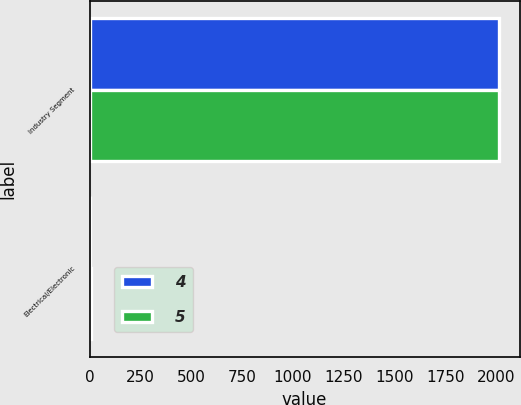Convert chart. <chart><loc_0><loc_0><loc_500><loc_500><stacked_bar_chart><ecel><fcel>Industry Segment<fcel>Electrical/Electronic<nl><fcel>4<fcel>2011<fcel>4<nl><fcel>5<fcel>2014<fcel>5<nl></chart> 